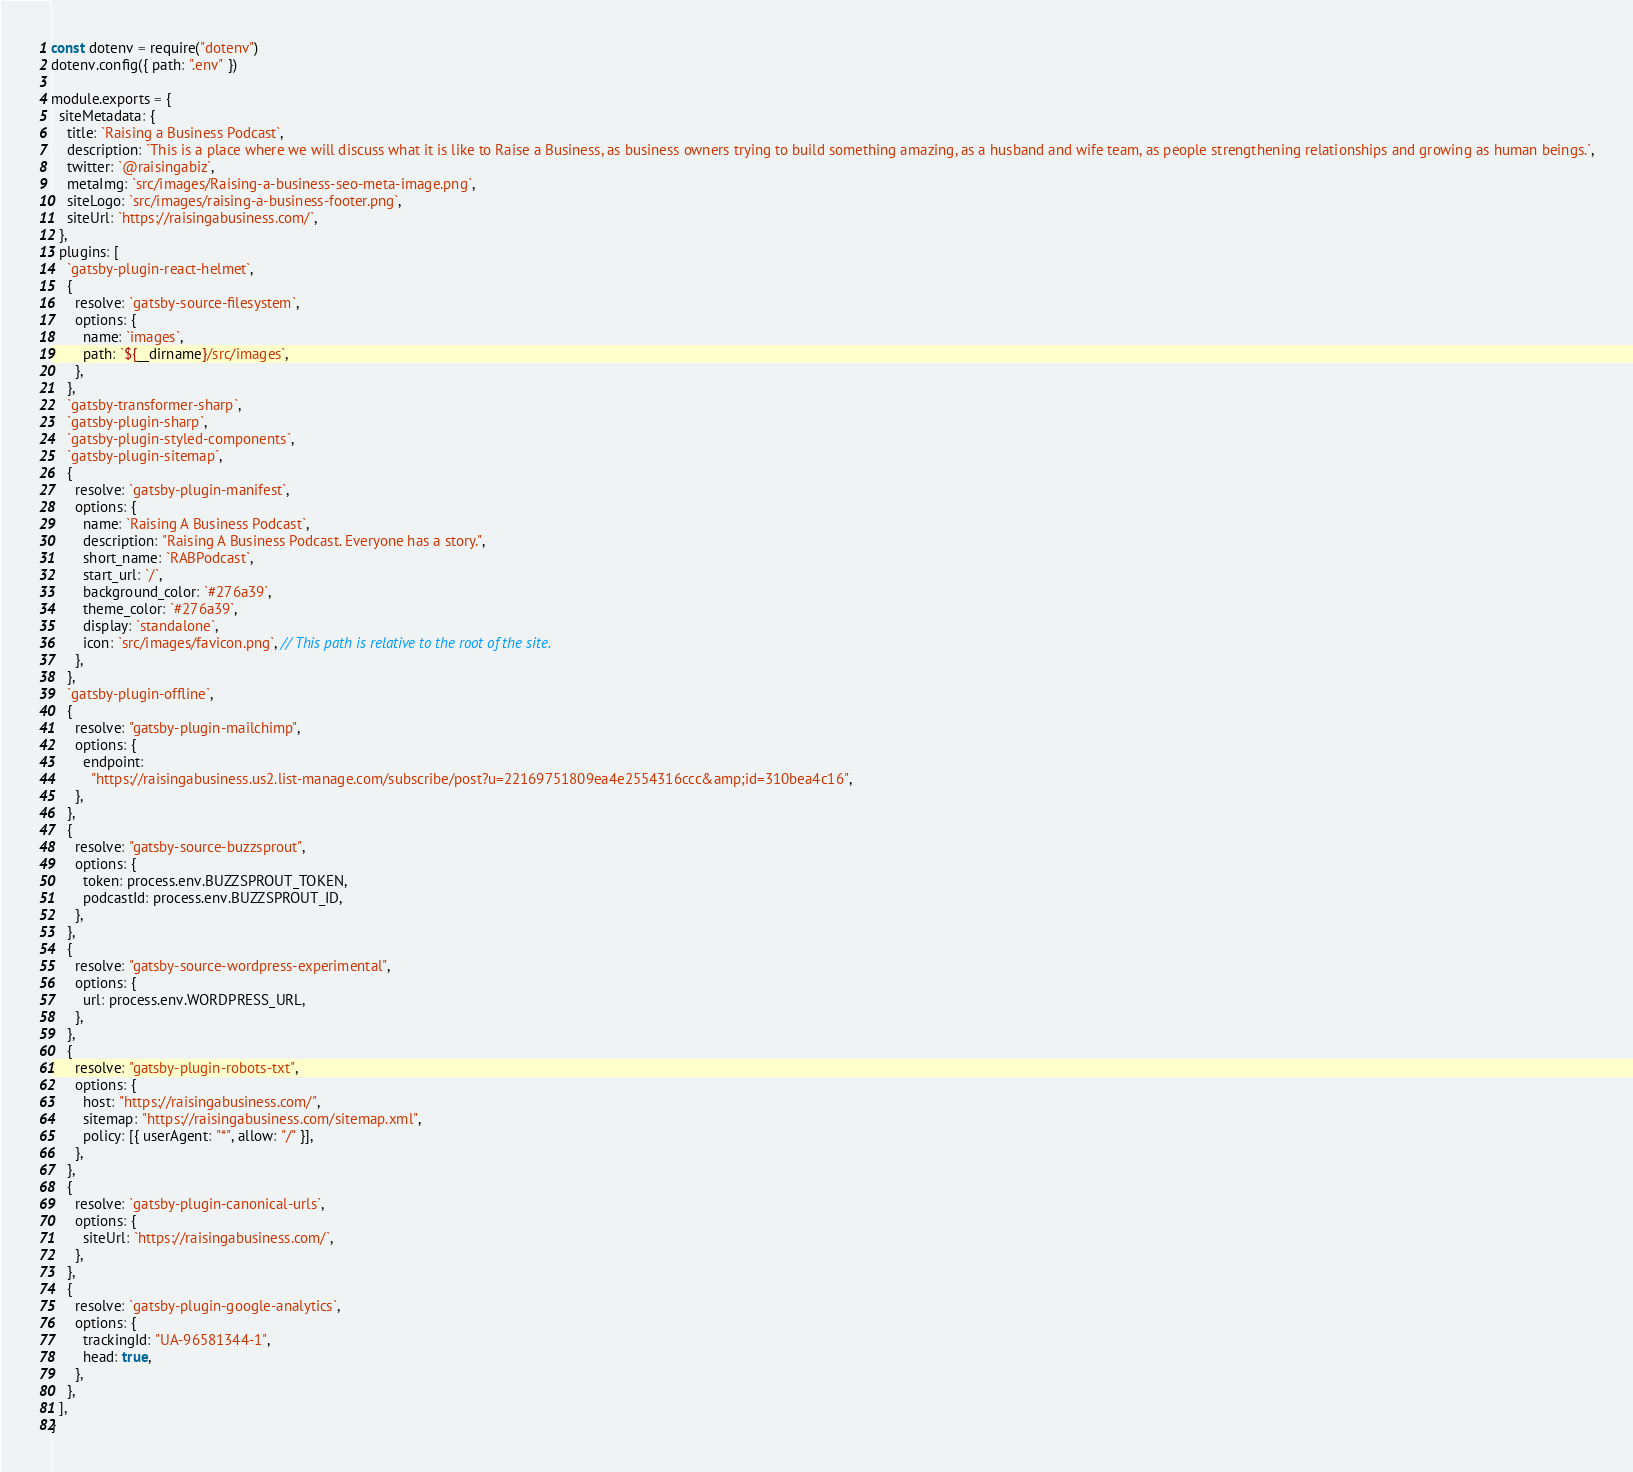<code> <loc_0><loc_0><loc_500><loc_500><_JavaScript_>const dotenv = require("dotenv")
dotenv.config({ path: ".env" })

module.exports = {
  siteMetadata: {
    title: `Raising a Business Podcast`,
    description: `This is a place where we will discuss what it is like to Raise a Business, as business owners trying to build something amazing, as a husband and wife team, as people strengthening relationships and growing as human beings.`,
    twitter: `@raisingabiz`,
    metaImg: `src/images/Raising-a-business-seo-meta-image.png`,
    siteLogo: `src/images/raising-a-business-footer.png`,
    siteUrl: `https://raisingabusiness.com/`,
  },
  plugins: [
    `gatsby-plugin-react-helmet`,
    {
      resolve: `gatsby-source-filesystem`,
      options: {
        name: `images`,
        path: `${__dirname}/src/images`,
      },
    },
    `gatsby-transformer-sharp`,
    `gatsby-plugin-sharp`,
    `gatsby-plugin-styled-components`,
    `gatsby-plugin-sitemap`,
    {
      resolve: `gatsby-plugin-manifest`,
      options: {
        name: `Raising A Business Podcast`,
        description: "Raising A Business Podcast. Everyone has a story.",
        short_name: `RABPodcast`,
        start_url: `/`,
        background_color: `#276a39`,
        theme_color: `#276a39`,
        display: `standalone`,
        icon: `src/images/favicon.png`, // This path is relative to the root of the site.
      },
    },
    `gatsby-plugin-offline`,
    {
      resolve: "gatsby-plugin-mailchimp",
      options: {
        endpoint:
          "https://raisingabusiness.us2.list-manage.com/subscribe/post?u=22169751809ea4e2554316ccc&amp;id=310bea4c16",
      },
    },
    {
      resolve: "gatsby-source-buzzsprout",
      options: {
        token: process.env.BUZZSPROUT_TOKEN,
        podcastId: process.env.BUZZSPROUT_ID,
      },
    },
    {
      resolve: "gatsby-source-wordpress-experimental",
      options: {
        url: process.env.WORDPRESS_URL,
      },
    },
    {
      resolve: "gatsby-plugin-robots-txt",
      options: {
        host: "https://raisingabusiness.com/",
        sitemap: "https://raisingabusiness.com/sitemap.xml",
        policy: [{ userAgent: "*", allow: "/" }],
      },
    },
    {
      resolve: `gatsby-plugin-canonical-urls`,
      options: {
        siteUrl: `https://raisingabusiness.com/`,
      },
    },
    {
      resolve: `gatsby-plugin-google-analytics`,
      options: {
        trackingId: "UA-96581344-1",
        head: true,
      },
    },
  ],
}
</code> 